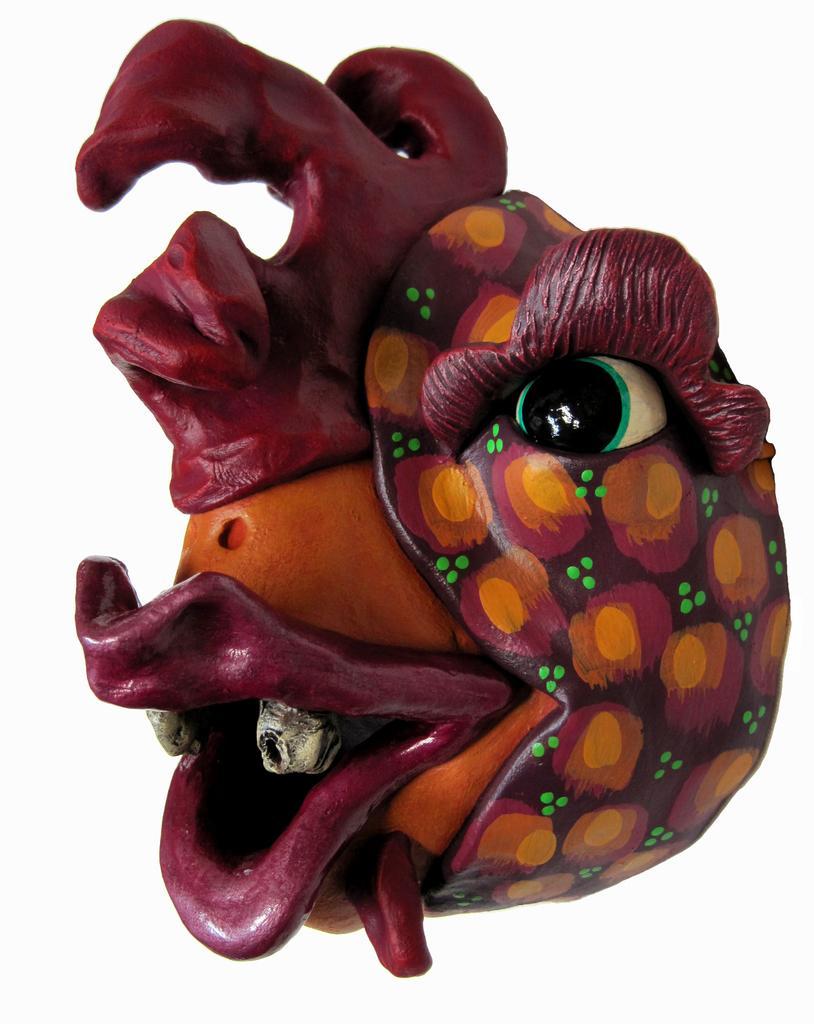In one or two sentences, can you explain what this image depicts? In this image we can see some kind of art, and the background is white. 